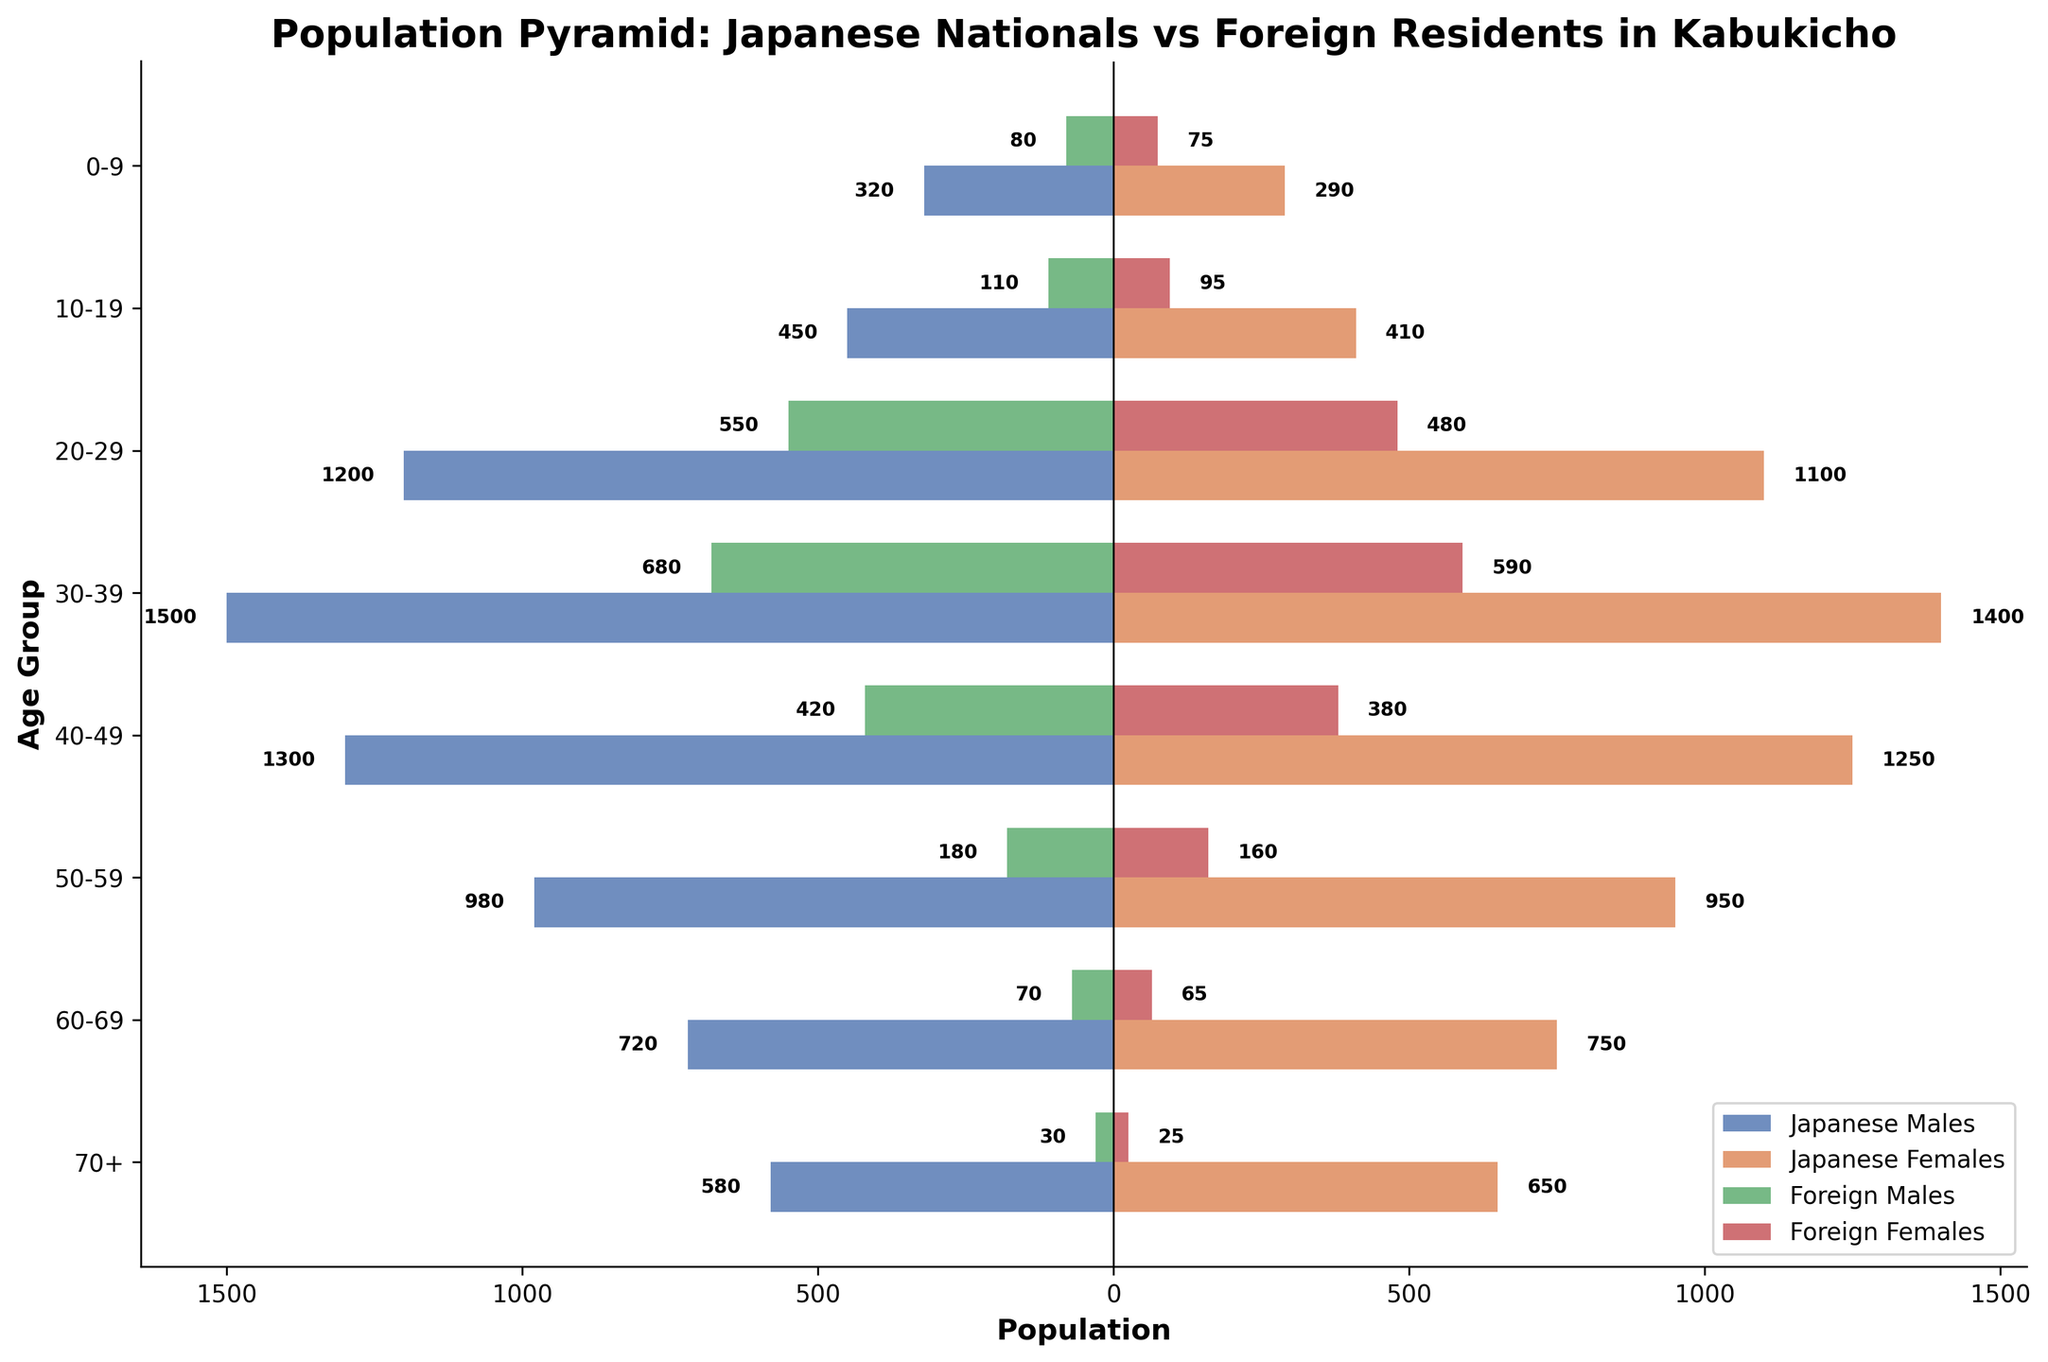How many total Japanese males are in the 20-29 age group? We can directly read the population value for Japanese males in the 20-29 age group from the figure, which is 1200.
Answer: 1200 Which age group has the highest number of foreign females? The bar representing the foreign females in the age group 30-39 is the longest, indicating the highest number. This age group has 590 foreign females.
Answer: 30-39 What is the difference in population between Japanese males and foreign males in the 40-49 age group? The population of Japanese males in the 40-49 age group is 1300, and the population of foreign males is 420. The difference is 1300 - 420 = 880.
Answer: 880 In the age group 10-19, which gender has a higher population, Japanese males or Japanese females? By comparing the length of the bars within the 10-19 age group, we see that the bar for Japanese males (450) is longer than that for Japanese females (410). Thus, Japanese males have the higher population.
Answer: Japanese males How does the population of foreign residents in the 60-69 age group compare to the same group in the 0-9 age group? The population of foreign residents in the 60-69 age group is (70 males + 65 females) = 135, while in the 0-9 age group it is (80 males + 75 females) = 155. Therefore, there are fewer foreign residents in the 60-69 age group compared to the 0-9.
Answer: Fewer Calculate the total population of Japanese nationals across all age groups. Sum the populations of Japanese males and females in all age groups: (320 + 450 + 1200 + 1500 + 1300 + 980 + 720 + 580) + (290 + 410 + 1100 + 1400 + 1250 + 950 + 750 + 650), which equals 7050.
Answer: 7050 Which age group has the smallest population of foreign males? The bar representing foreign males in the 70+ age group is the shortest with 30 foreign males, indicating the smallest population.
Answer: 70+ What is the total population difference between Japanese and foreign residents in the age group 50-59? The population of Japanese residents in the 50-59 age group is (980 males + 950 females) = 1930, and the population of foreign residents is (180 males + 160 females) = 340. The total difference is 1930 - 340 = 1590.
Answer: 1590 Add the number of Japanese females in the 40-49 age group to the number of foreign males in the 20-29 age group. The population of Japanese females in the 40-49 age group is 1250, and the population of foreign males in the 20-29 age group is 550. Their sum is 1250 + 550 = 1800.
Answer: 1800 